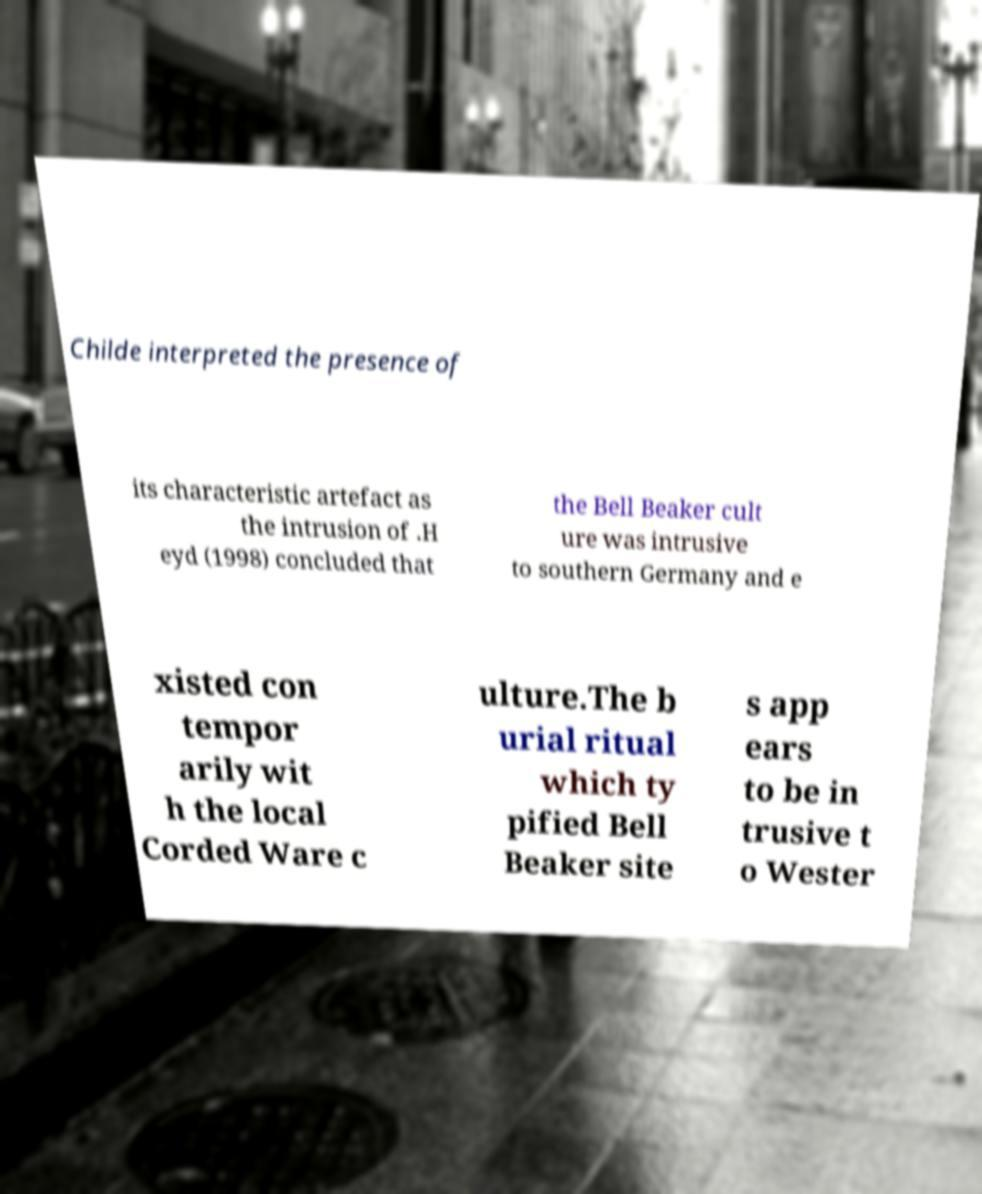There's text embedded in this image that I need extracted. Can you transcribe it verbatim? Childe interpreted the presence of its characteristic artefact as the intrusion of .H eyd (1998) concluded that the Bell Beaker cult ure was intrusive to southern Germany and e xisted con tempor arily wit h the local Corded Ware c ulture.The b urial ritual which ty pified Bell Beaker site s app ears to be in trusive t o Wester 